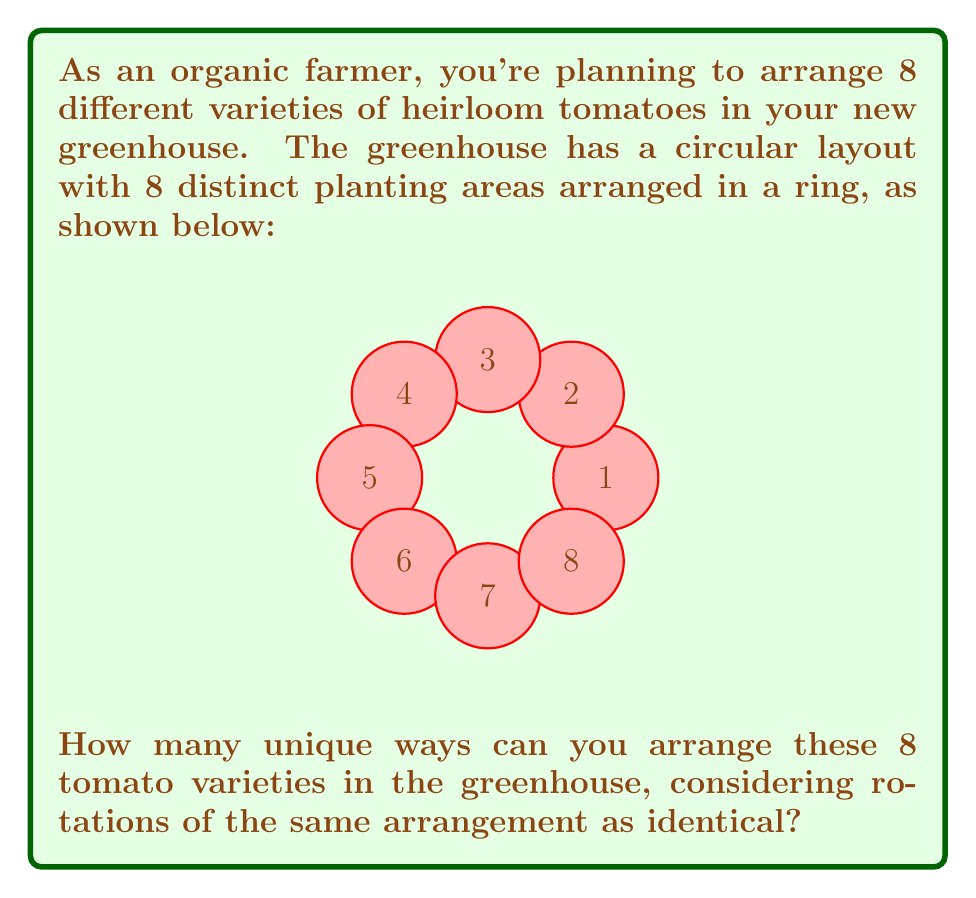Could you help me with this problem? Let's approach this step-by-step:

1) First, we need to recognize that this is a circular permutation problem. In a circular arrangement, rotations of the same arrangement are considered identical.

2) For linear arrangements of n distinct objects, we would have n! permutations. However, for circular arrangements, we need to adjust this.

3) In a circular arrangement of n objects, each arrangement can be rotated n ways and still be considered the same arrangement. Therefore, we need to divide the total number of linear permutations by n.

4) The formula for circular permutations of n distinct objects is:

   $$(n-1)!$$

5) In this case, we have 8 distinct tomato varieties. So, n = 8.

6) Applying the formula:

   Number of unique arrangements = $(8-1)!$ = $7!$

7) Calculate $7!$:
   
   $7! = 7 \times 6 \times 5 \times 4 \times 3 \times 2 \times 1 = 5040$

Therefore, there are 5040 unique ways to arrange the 8 tomato varieties in the circular greenhouse.
Answer: 5040 